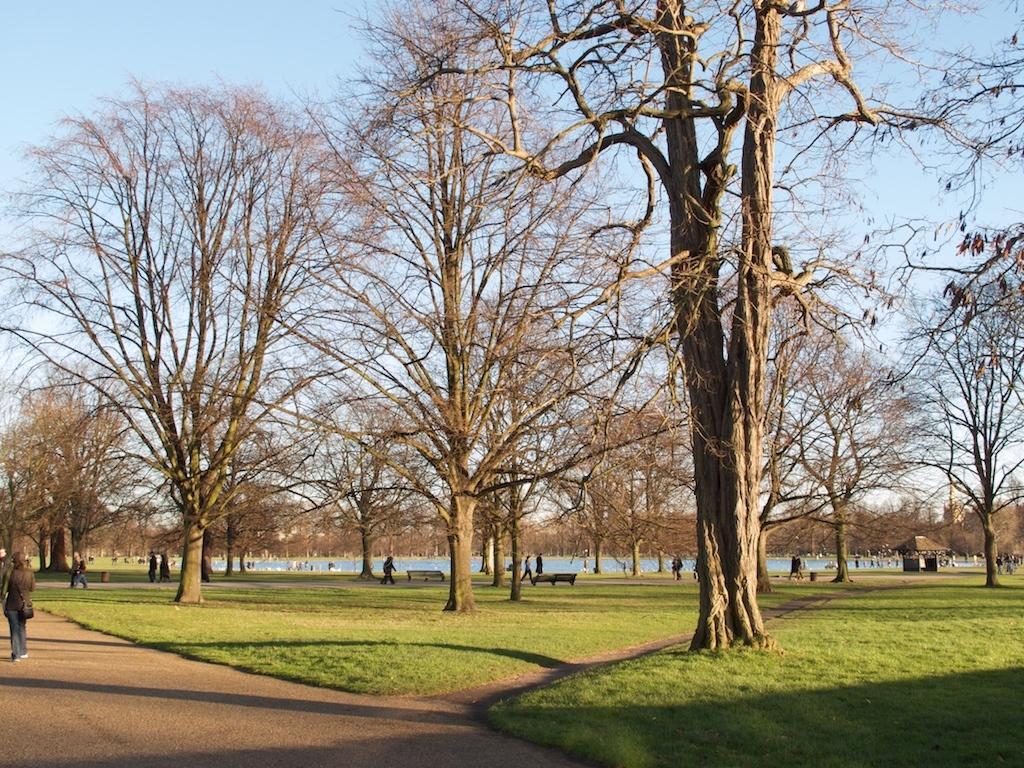Describe this image in one or two sentences. In this picture I can see green grass. I can see trees. I can see people on the walkway. I can see water. I can see clouds in the sky. 